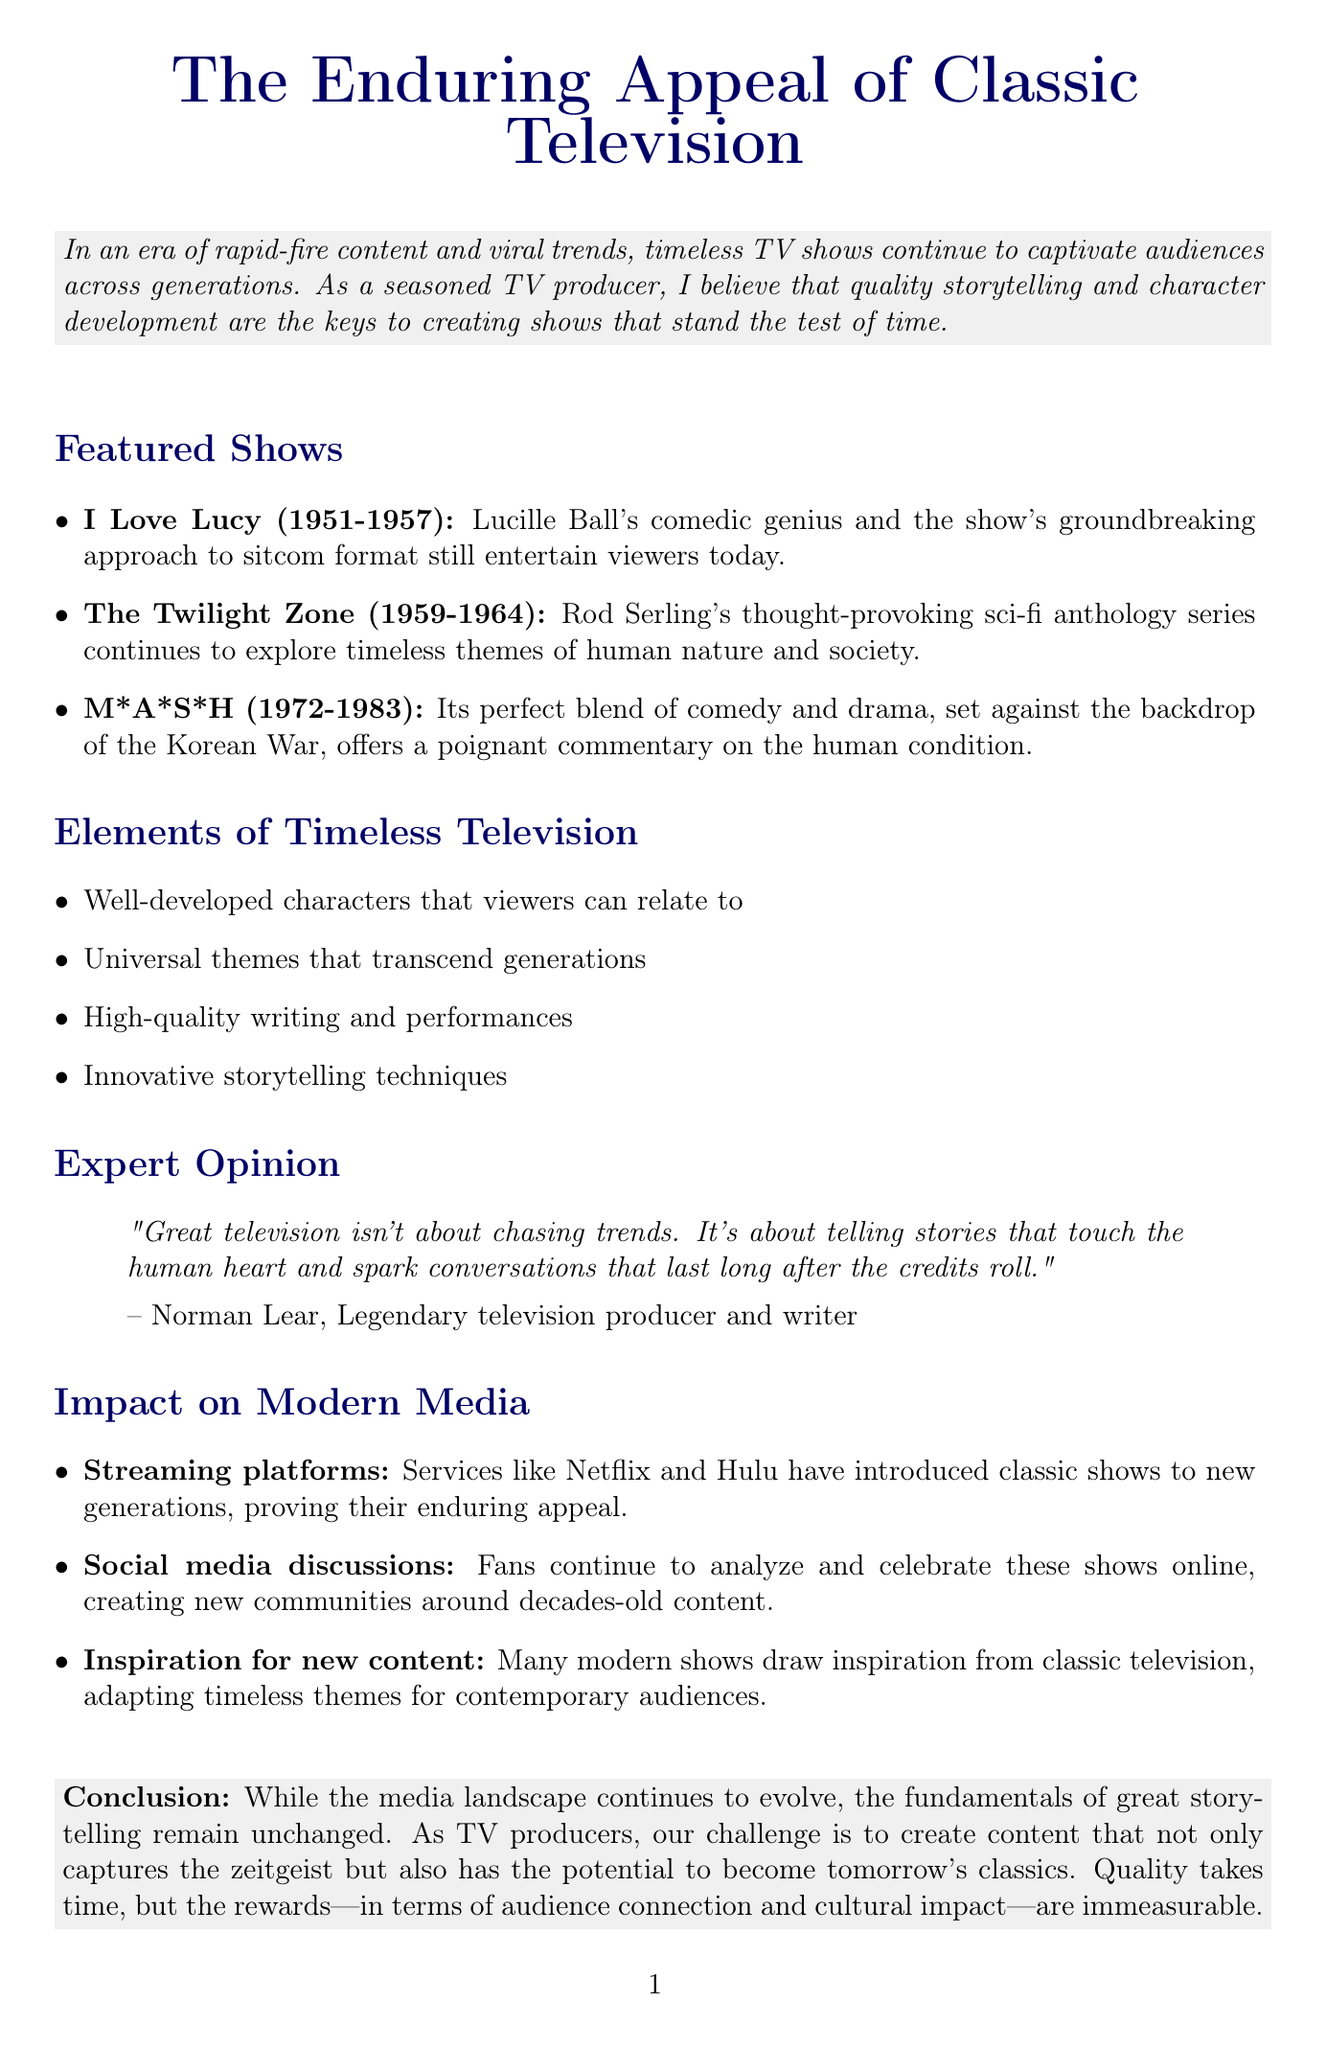what is the title of the newsletter? The title of the newsletter is clearly stated at the beginning of the document.
Answer: The Enduring Appeal of Classic Television who is the expert quoted in the newsletter? The expert's name is mentioned in the "Expert Opinion" section.
Answer: Norman Lear what year did "I Love Lucy" originally air? The original airing year for "I Love Lucy" is provided under the featured shows section.
Answer: 1951-1957 how many timeless elements are listed in the document? The list of timeless elements is presented in the respective section of the newsletter.
Answer: Four what is the main theme of "The Twilight Zone"? The reasoning for the show's resonance is provided within its description in the featured shows section.
Answer: Human nature and society which streaming platforms are mentioned as introducing classic shows to new generations? The specific platforms are listed in the "Impact on Modern Media" section.
Answer: Netflix and Hulu what central philosophy does Norman Lear emphasize about great television? The essence of Lear's statement highlights the importance of storytelling, as noted in his quote.
Answer: Quality storytelling which classic show blends comedy and drama set against a historical backdrop? The featured shows section provides details on each show's characteristics, pointing to one specific show.
Answer: M*A*S*H 